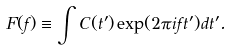<formula> <loc_0><loc_0><loc_500><loc_500>F ( f ) \equiv \int C ( t ^ { \prime } ) \exp ( 2 \pi i f t ^ { \prime } ) d t ^ { \prime } .</formula> 